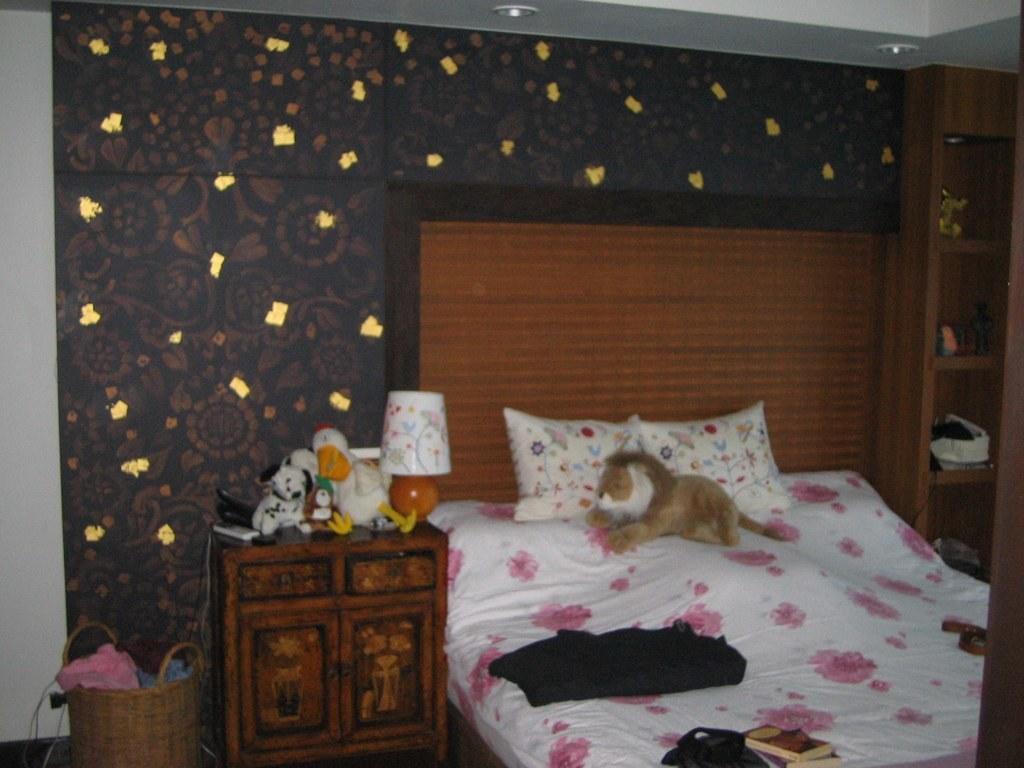What piece of furniture is present in the image? There is a bed in the image. What items can be seen on the bed? There are toys and a bag on the bed. Are there any toys located elsewhere in the image? Yes, there are toys on a table. What is on the table with the toys? There is a table lamp on the table. What type of pain is the person experiencing in the image? There is no person present in the image, and therefore no indication of any pain being experienced. 